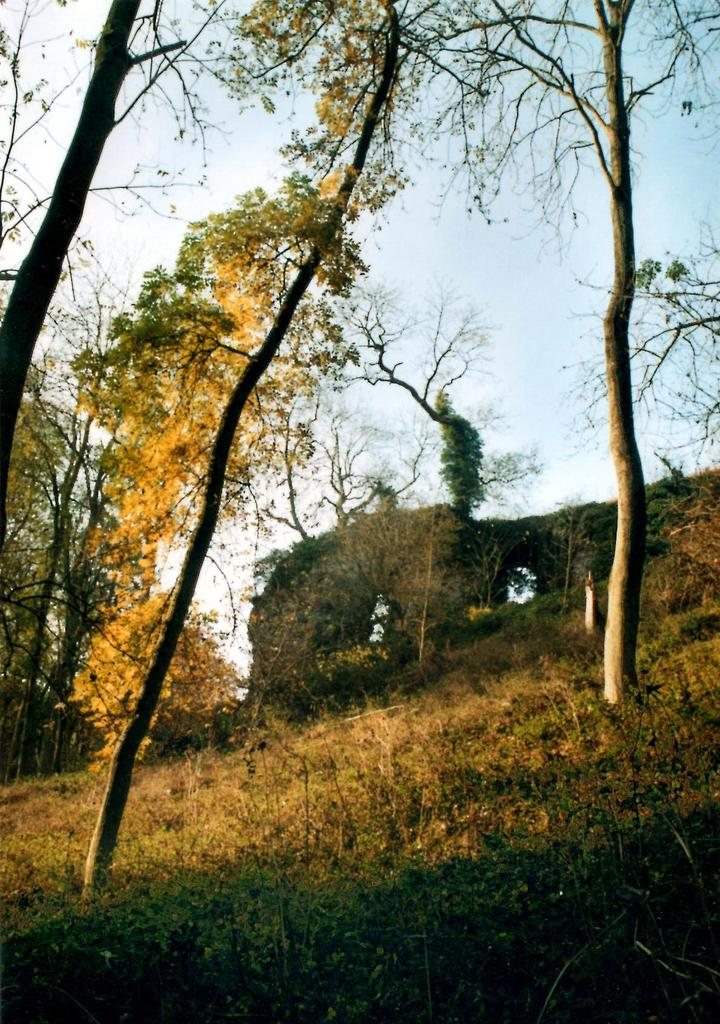What type of structure is present in the image? There is a building in the image. What other natural elements can be seen in the image? There are trees and grass in the image. What is visible in the background of the image? The sky is visible in the image. How many frogs can be seen writing in the yard in the image? There are no frogs or writing present in the image; it features a building, trees, grass, and the sky. 